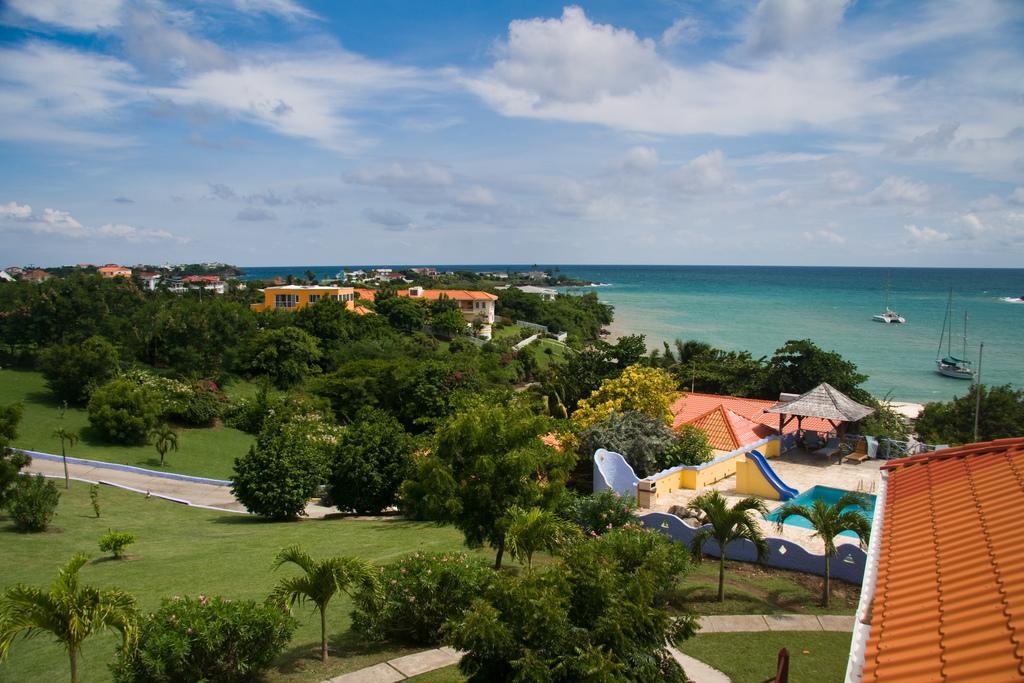In one or two sentences, can you explain what this image depicts? In this image I can see trees in green color. I can also see few buildings in cream, orange and white color, background I can see few boats on the water and the sky is in blue and white color. 